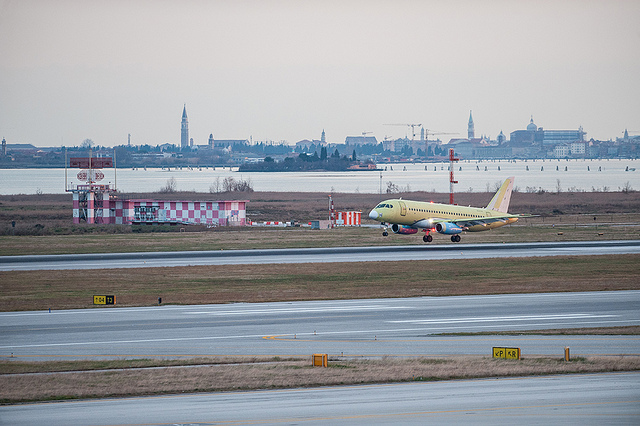<image>What model plane is this? I don't know the exact model of the plane. It could be an airbus a320, a 727, a 747, or a 760. What airport is this plane landing at? I don't know what airport this plane is landing at. The responses suggest it could be Heathrow, O'Hare, an airport in Italy, Oklahoma, Manchester, Chicago, London, or LaGuardia. What model plane is this? I don't know what model plane it is. What airport is this plane landing at? I don't know the exact airport this plane is landing at. It could be Heathrow, O'Hare, Italy, Oklahoma, Manchester, Chicago, London, LaGuardia, or an unknown airport. 